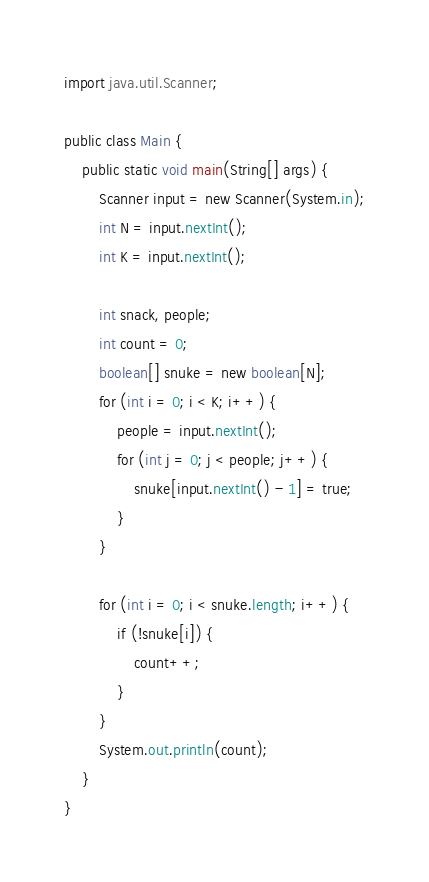Convert code to text. <code><loc_0><loc_0><loc_500><loc_500><_Java_>import java.util.Scanner;

public class Main {
    public static void main(String[] args) {
        Scanner input = new Scanner(System.in);
        int N = input.nextInt();
        int K = input.nextInt();

        int snack, people;
        int count = 0;
        boolean[] snuke = new boolean[N];
        for (int i = 0; i < K; i++) {
            people = input.nextInt();
            for (int j = 0; j < people; j++) {
                snuke[input.nextInt() - 1] = true;
            }
        }

        for (int i = 0; i < snuke.length; i++) {
            if (!snuke[i]) {
                count++;
            }
        }
        System.out.println(count);
    }
}
</code> 